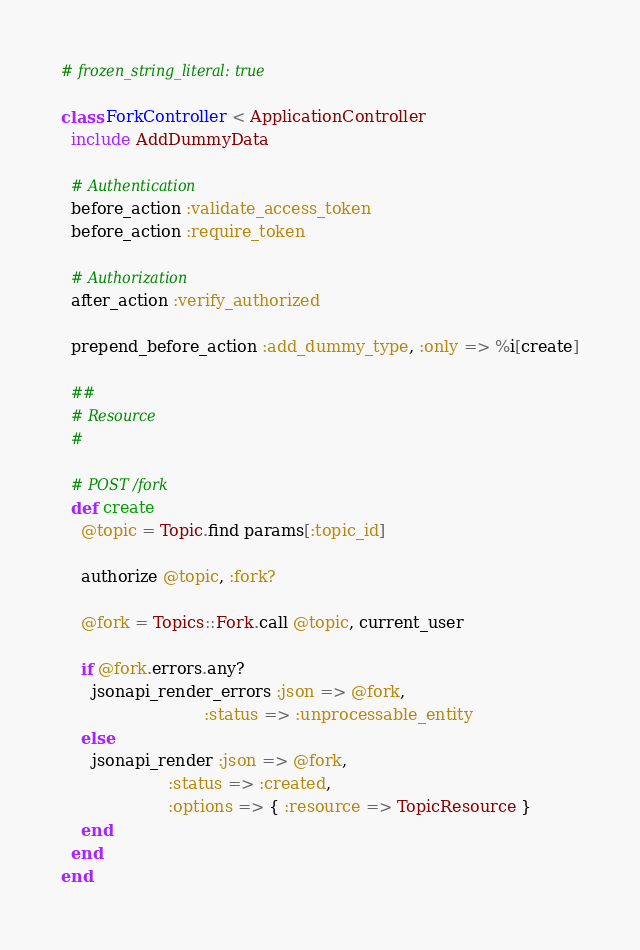<code> <loc_0><loc_0><loc_500><loc_500><_Ruby_># frozen_string_literal: true

class ForkController < ApplicationController
  include AddDummyData

  # Authentication
  before_action :validate_access_token
  before_action :require_token

  # Authorization
  after_action :verify_authorized

  prepend_before_action :add_dummy_type, :only => %i[create]

  ##
  # Resource
  #

  # POST /fork
  def create
    @topic = Topic.find params[:topic_id]

    authorize @topic, :fork?

    @fork = Topics::Fork.call @topic, current_user

    if @fork.errors.any?
      jsonapi_render_errors :json => @fork,
                            :status => :unprocessable_entity
    else
      jsonapi_render :json => @fork,
                     :status => :created,
                     :options => { :resource => TopicResource }
    end
  end
end
</code> 